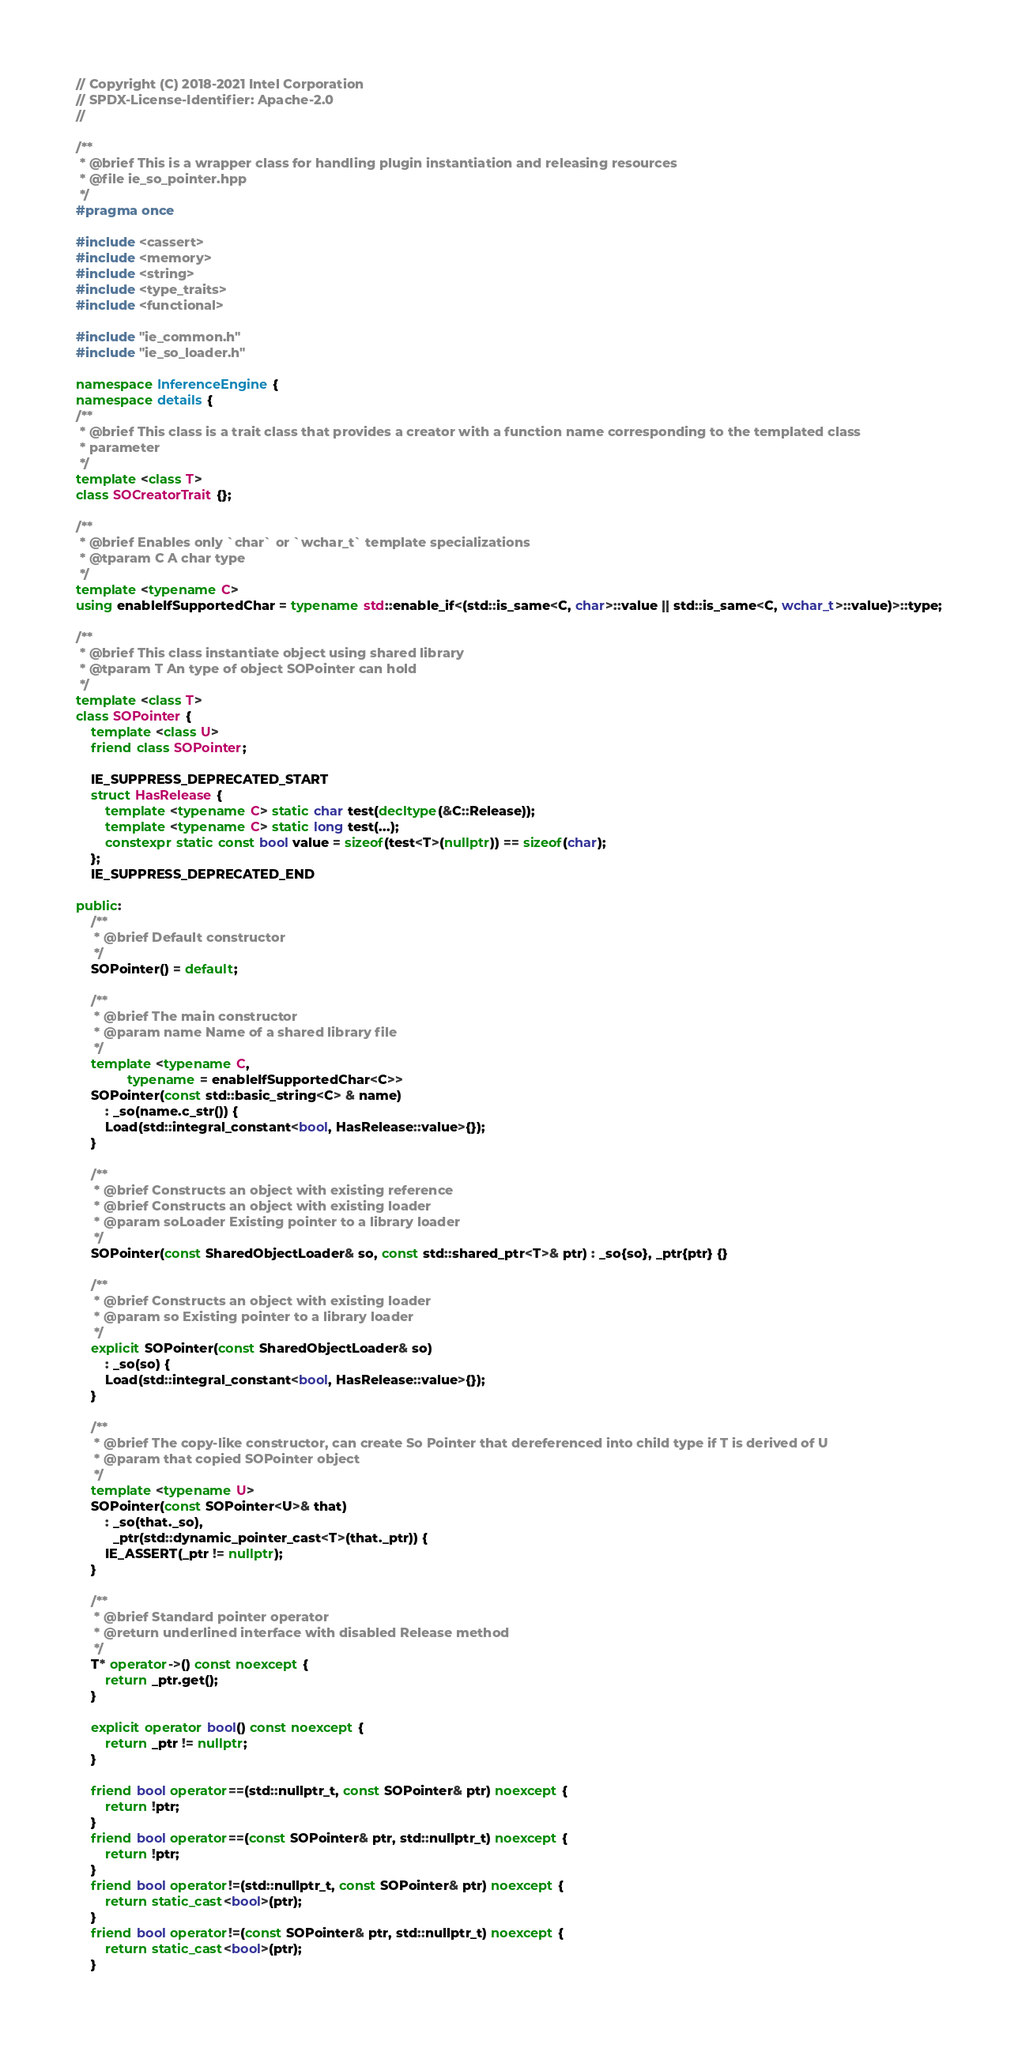Convert code to text. <code><loc_0><loc_0><loc_500><loc_500><_C++_>// Copyright (C) 2018-2021 Intel Corporation
// SPDX-License-Identifier: Apache-2.0
//

/**
 * @brief This is a wrapper class for handling plugin instantiation and releasing resources
 * @file ie_so_pointer.hpp
 */
#pragma once

#include <cassert>
#include <memory>
#include <string>
#include <type_traits>
#include <functional>

#include "ie_common.h"
#include "ie_so_loader.h"

namespace InferenceEngine {
namespace details {
/**
 * @brief This class is a trait class that provides a creator with a function name corresponding to the templated class
 * parameter
 */
template <class T>
class SOCreatorTrait {};

/**
 * @brief Enables only `char` or `wchar_t` template specializations
 * @tparam C A char type
 */
template <typename C>
using enableIfSupportedChar = typename std::enable_if<(std::is_same<C, char>::value || std::is_same<C, wchar_t>::value)>::type;

/**
 * @brief This class instantiate object using shared library
 * @tparam T An type of object SOPointer can hold
 */
template <class T>
class SOPointer {
    template <class U>
    friend class SOPointer;

    IE_SUPPRESS_DEPRECATED_START
    struct HasRelease {
        template <typename C> static char test(decltype(&C::Release));
        template <typename C> static long test(...);
        constexpr static const bool value = sizeof(test<T>(nullptr)) == sizeof(char);
    };
    IE_SUPPRESS_DEPRECATED_END

public:
    /**
     * @brief Default constructor
     */
    SOPointer() = default;

    /**
     * @brief The main constructor
     * @param name Name of a shared library file
     */
    template <typename C,
              typename = enableIfSupportedChar<C>>
    SOPointer(const std::basic_string<C> & name)
        : _so(name.c_str()) {
        Load(std::integral_constant<bool, HasRelease::value>{});
    }

    /**
     * @brief Constructs an object with existing reference
     * @brief Constructs an object with existing loader
     * @param soLoader Existing pointer to a library loader
     */
    SOPointer(const SharedObjectLoader& so, const std::shared_ptr<T>& ptr) : _so{so}, _ptr{ptr} {}

    /**
     * @brief Constructs an object with existing loader
     * @param so Existing pointer to a library loader
     */
    explicit SOPointer(const SharedObjectLoader& so)
        : _so(so) {
        Load(std::integral_constant<bool, HasRelease::value>{});
    }

    /**
     * @brief The copy-like constructor, can create So Pointer that dereferenced into child type if T is derived of U
     * @param that copied SOPointer object
     */
    template <typename U>
    SOPointer(const SOPointer<U>& that)
        : _so(that._so),
          _ptr(std::dynamic_pointer_cast<T>(that._ptr)) {
        IE_ASSERT(_ptr != nullptr);
    }

    /**
     * @brief Standard pointer operator
     * @return underlined interface with disabled Release method
     */
    T* operator->() const noexcept {
        return _ptr.get();
    }

    explicit operator bool() const noexcept {
        return _ptr != nullptr;
    }

    friend bool operator==(std::nullptr_t, const SOPointer& ptr) noexcept {
        return !ptr;
    }
    friend bool operator==(const SOPointer& ptr, std::nullptr_t) noexcept {
        return !ptr;
    }
    friend bool operator!=(std::nullptr_t, const SOPointer& ptr) noexcept {
        return static_cast<bool>(ptr);
    }
    friend bool operator!=(const SOPointer& ptr, std::nullptr_t) noexcept {
        return static_cast<bool>(ptr);
    }
</code> 